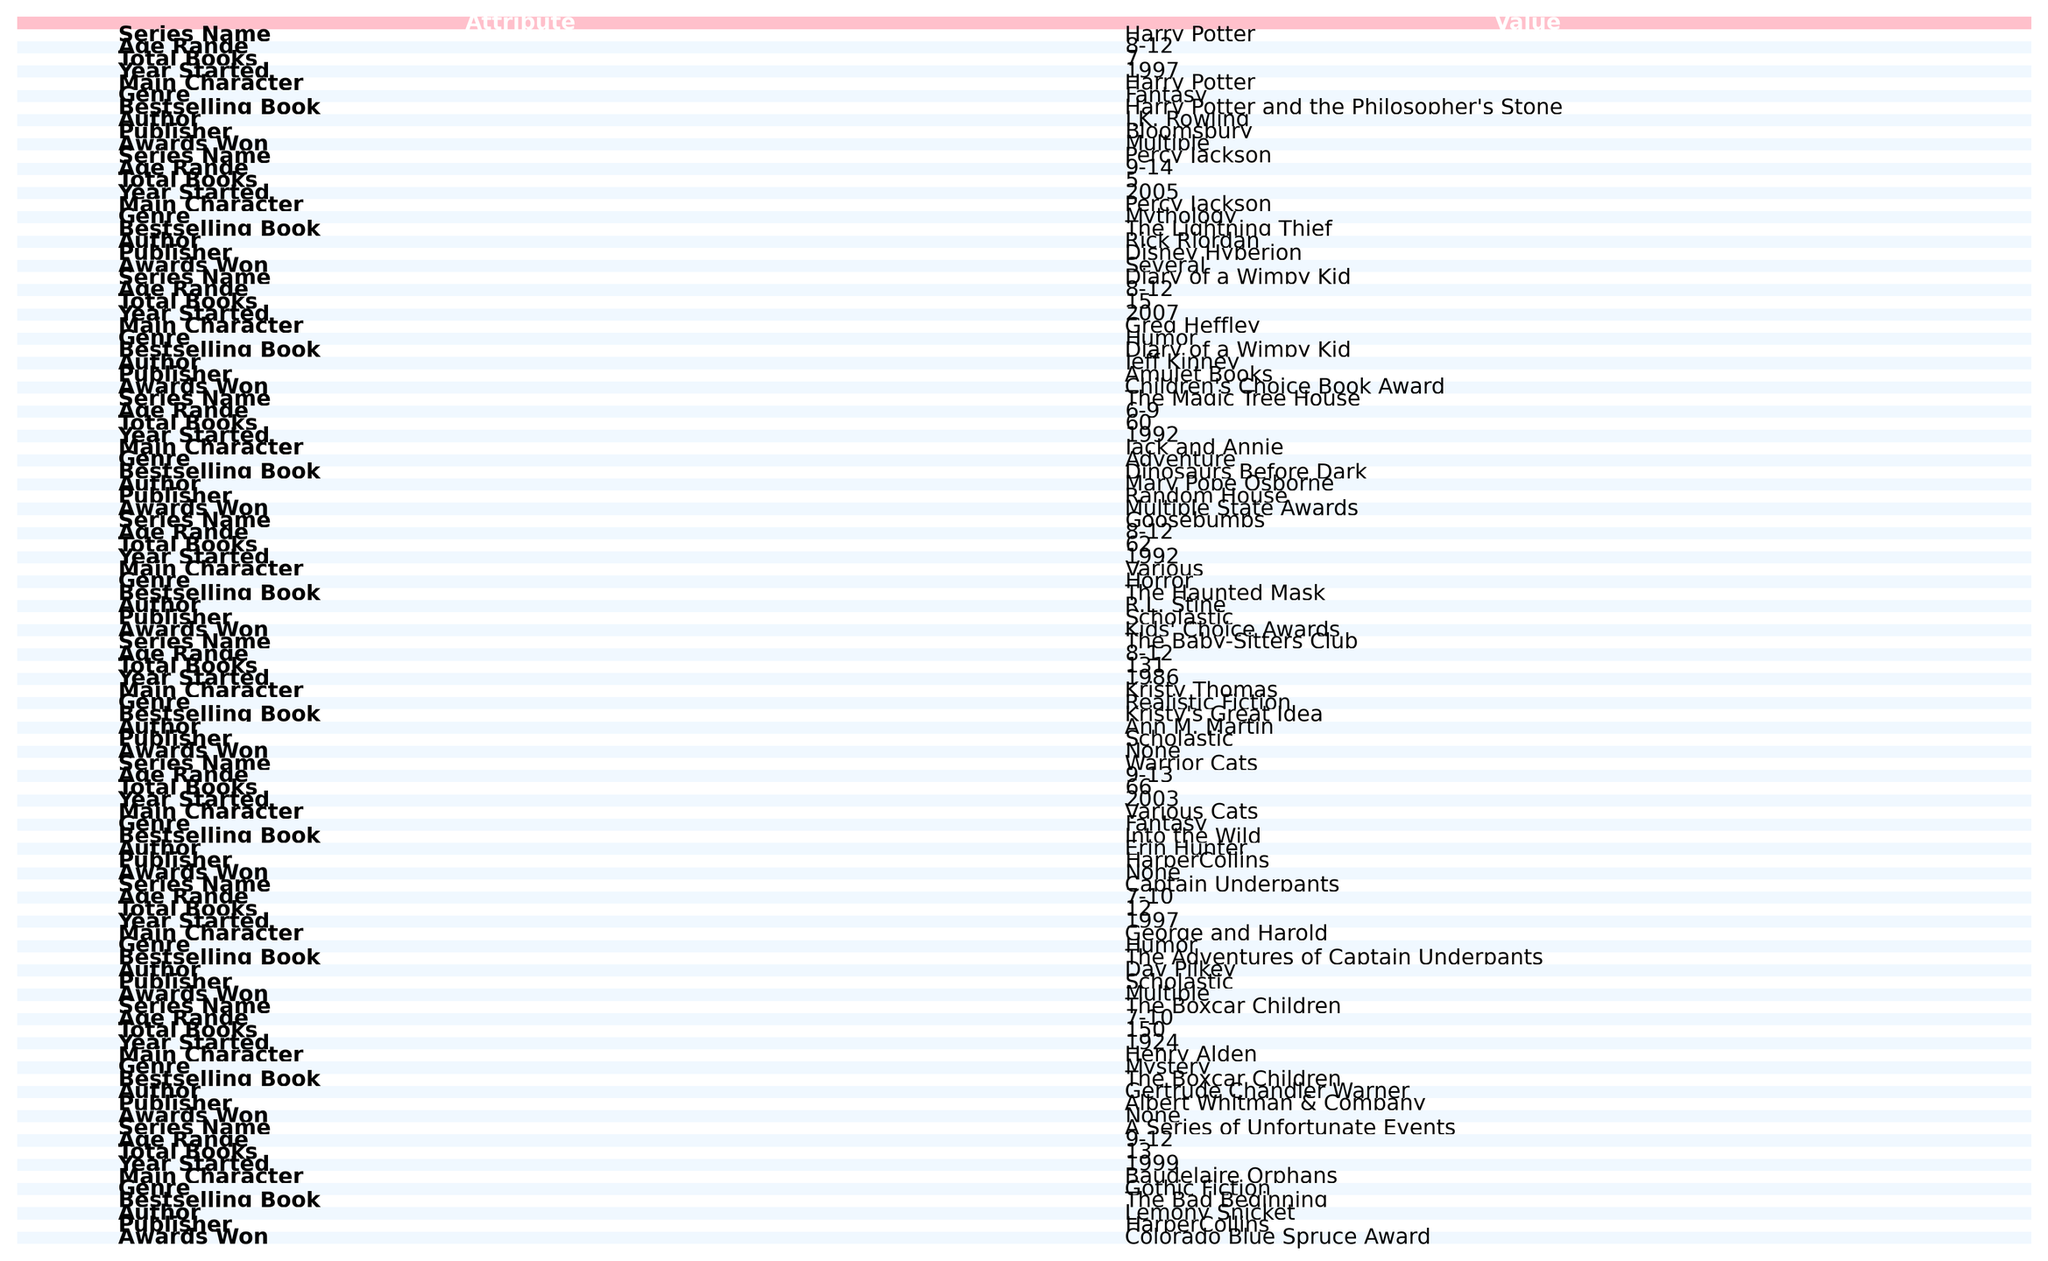What is the age range for the Harry Potter series? The table directly shows the age range listed next to the Harry Potter series, which is 8-12.
Answer: 8-12 How many books are in The Baby-Sitters Club series? Under the total books column for The Baby-Sitters Club, there is a value of 131 books.
Answer: 131 What genre does The Magic Tree House belong to? The genre for The Magic Tree House is categorized as Adventure in the table.
Answer: Adventure Is Goosebumps a horror series? The table indicates that Goosebumps is categorized under the Horror genre, confirming it is a horror series.
Answer: Yes Which series has the most total books? By comparing the total books listed, The Baby-Sitters Club has the highest number at 131, while others have fewer.
Answer: The Baby-Sitters Club How many books are in the A Series of Unfortunate Events? The table shows that A Series of Unfortunate Events contains 13 books.
Answer: 13 Do any of these series start before 1990? Checking the Year Started column, both The Boxcar Children (1924) and The Baby-Sitters Club (1986) started before 1990.
Answer: Yes What is the average number of books across the series listed? Adding the total number of books together (7 + 5 + 15 + 60 + 62 + 131 + 66 + 12 + 150 + 13 = 511), and dividing by the number of series (10), gives an average of 51.1 books.
Answer: 51.1 What is the bestselling book in the Percy Jackson series? The table lists "The Lightning Thief" as the bestselling book of the Percy Jackson series.
Answer: The Lightning Thief How many series have won multiple awards? Reviewing the Awards Won column reveals that Harry Potter, The Magic Tree House, Goosebumps, Captain Underpants, and Diary of a Wimpy Kid have all won multiple awards, making it 5 series in total.
Answer: 5 Which series features animals as main characters? The Warrior Cats series lists "Various Cats" as the main character, indicating it features animals.
Answer: Warrior Cats 